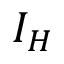<formula> <loc_0><loc_0><loc_500><loc_500>I _ { H }</formula> 